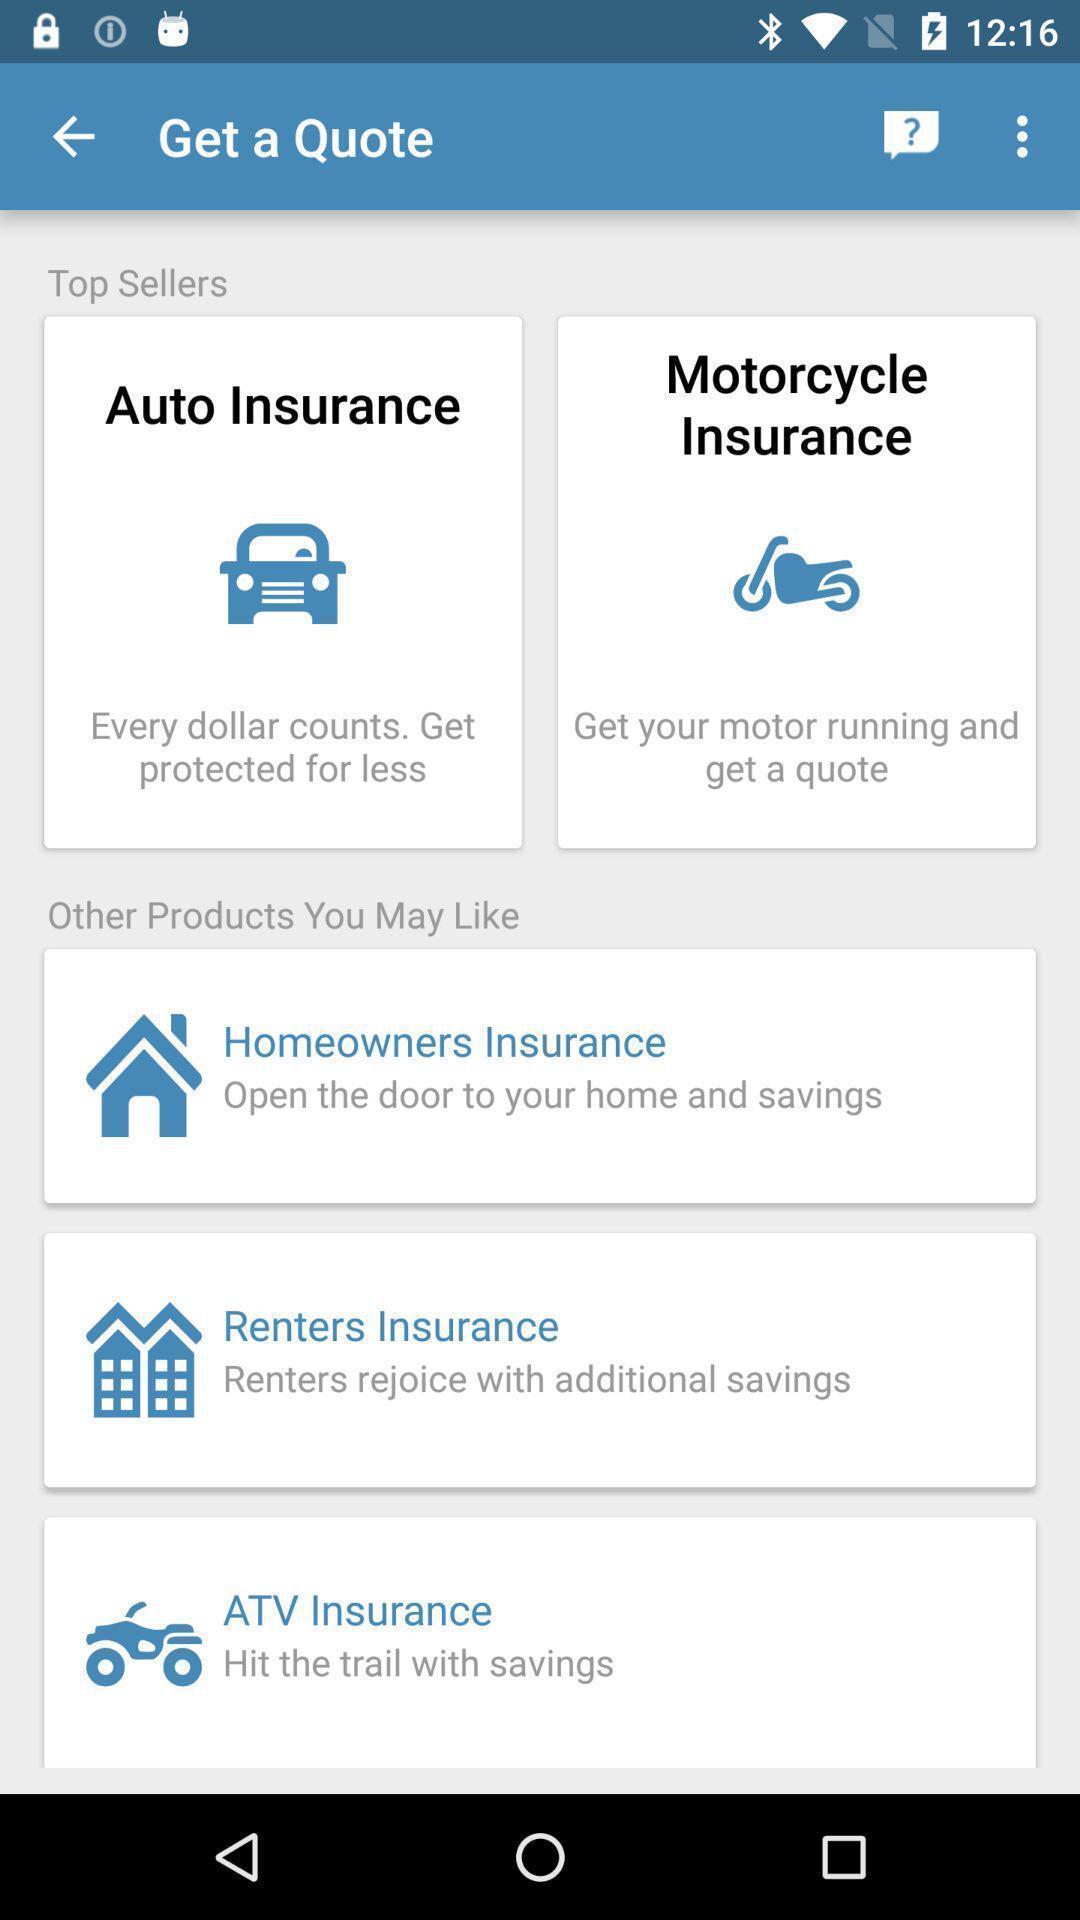Describe the key features of this screenshot. Window displaying about all types of insurances. 